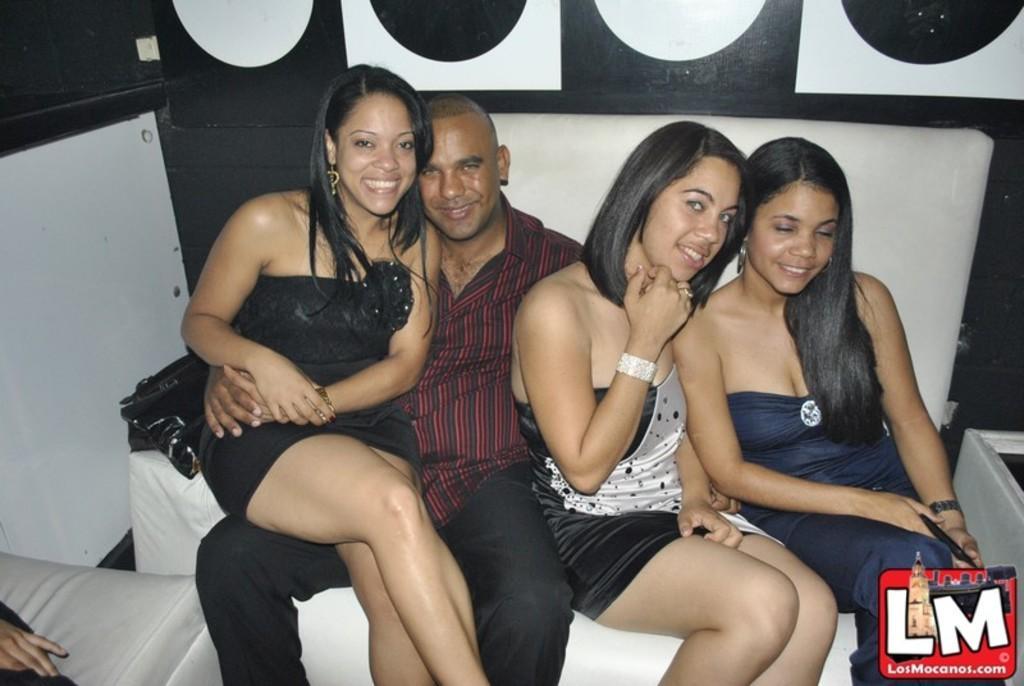Describe this image in one or two sentences. In the image there are four people, a man and three women. All of them posing for the photo and behind the people there is a wall. 